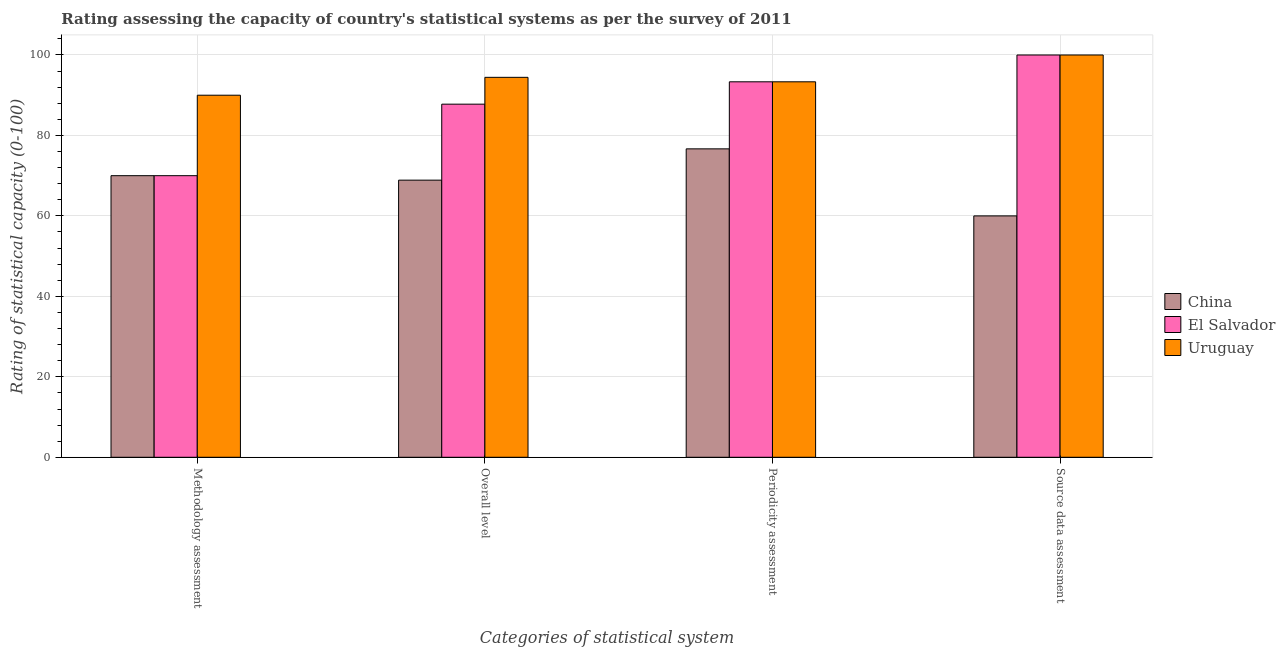How many groups of bars are there?
Offer a terse response. 4. Are the number of bars on each tick of the X-axis equal?
Your response must be concise. Yes. How many bars are there on the 2nd tick from the right?
Your answer should be compact. 3. What is the label of the 1st group of bars from the left?
Keep it short and to the point. Methodology assessment. What is the periodicity assessment rating in El Salvador?
Your answer should be very brief. 93.33. Across all countries, what is the maximum overall level rating?
Provide a short and direct response. 94.44. In which country was the methodology assessment rating maximum?
Offer a very short reply. Uruguay. What is the total overall level rating in the graph?
Offer a terse response. 251.11. What is the difference between the source data assessment rating in El Salvador and that in China?
Make the answer very short. 40. What is the difference between the periodicity assessment rating in China and the source data assessment rating in El Salvador?
Provide a short and direct response. -23.33. What is the average overall level rating per country?
Your response must be concise. 83.7. What is the difference between the overall level rating and methodology assessment rating in Uruguay?
Your answer should be very brief. 4.44. In how many countries, is the source data assessment rating greater than 68 ?
Keep it short and to the point. 2. Is the source data assessment rating in China less than that in Uruguay?
Make the answer very short. Yes. Is the difference between the methodology assessment rating in China and Uruguay greater than the difference between the source data assessment rating in China and Uruguay?
Offer a very short reply. Yes. What is the difference between the highest and the lowest periodicity assessment rating?
Provide a succinct answer. 16.67. In how many countries, is the methodology assessment rating greater than the average methodology assessment rating taken over all countries?
Ensure brevity in your answer.  1. What does the 2nd bar from the left in Source data assessment represents?
Make the answer very short. El Salvador. What does the 1st bar from the right in Periodicity assessment represents?
Give a very brief answer. Uruguay. Is it the case that in every country, the sum of the methodology assessment rating and overall level rating is greater than the periodicity assessment rating?
Give a very brief answer. Yes. How many countries are there in the graph?
Give a very brief answer. 3. What is the difference between two consecutive major ticks on the Y-axis?
Give a very brief answer. 20. Are the values on the major ticks of Y-axis written in scientific E-notation?
Keep it short and to the point. No. Does the graph contain any zero values?
Provide a succinct answer. No. Does the graph contain grids?
Offer a terse response. Yes. How are the legend labels stacked?
Provide a succinct answer. Vertical. What is the title of the graph?
Make the answer very short. Rating assessing the capacity of country's statistical systems as per the survey of 2011 . Does "China" appear as one of the legend labels in the graph?
Your answer should be compact. Yes. What is the label or title of the X-axis?
Your answer should be very brief. Categories of statistical system. What is the label or title of the Y-axis?
Ensure brevity in your answer.  Rating of statistical capacity (0-100). What is the Rating of statistical capacity (0-100) in Uruguay in Methodology assessment?
Your response must be concise. 90. What is the Rating of statistical capacity (0-100) of China in Overall level?
Your answer should be very brief. 68.89. What is the Rating of statistical capacity (0-100) in El Salvador in Overall level?
Offer a terse response. 87.78. What is the Rating of statistical capacity (0-100) in Uruguay in Overall level?
Provide a succinct answer. 94.44. What is the Rating of statistical capacity (0-100) of China in Periodicity assessment?
Your answer should be very brief. 76.67. What is the Rating of statistical capacity (0-100) of El Salvador in Periodicity assessment?
Offer a very short reply. 93.33. What is the Rating of statistical capacity (0-100) of Uruguay in Periodicity assessment?
Your answer should be compact. 93.33. What is the Rating of statistical capacity (0-100) in El Salvador in Source data assessment?
Your answer should be compact. 100. What is the Rating of statistical capacity (0-100) in Uruguay in Source data assessment?
Keep it short and to the point. 100. Across all Categories of statistical system, what is the maximum Rating of statistical capacity (0-100) of China?
Provide a succinct answer. 76.67. Across all Categories of statistical system, what is the maximum Rating of statistical capacity (0-100) in El Salvador?
Offer a very short reply. 100. Across all Categories of statistical system, what is the maximum Rating of statistical capacity (0-100) of Uruguay?
Offer a very short reply. 100. Across all Categories of statistical system, what is the minimum Rating of statistical capacity (0-100) in El Salvador?
Your answer should be compact. 70. Across all Categories of statistical system, what is the minimum Rating of statistical capacity (0-100) in Uruguay?
Offer a terse response. 90. What is the total Rating of statistical capacity (0-100) of China in the graph?
Keep it short and to the point. 275.56. What is the total Rating of statistical capacity (0-100) in El Salvador in the graph?
Provide a short and direct response. 351.11. What is the total Rating of statistical capacity (0-100) of Uruguay in the graph?
Provide a succinct answer. 377.78. What is the difference between the Rating of statistical capacity (0-100) of El Salvador in Methodology assessment and that in Overall level?
Give a very brief answer. -17.78. What is the difference between the Rating of statistical capacity (0-100) in Uruguay in Methodology assessment and that in Overall level?
Provide a short and direct response. -4.44. What is the difference between the Rating of statistical capacity (0-100) in China in Methodology assessment and that in Periodicity assessment?
Ensure brevity in your answer.  -6.67. What is the difference between the Rating of statistical capacity (0-100) in El Salvador in Methodology assessment and that in Periodicity assessment?
Give a very brief answer. -23.33. What is the difference between the Rating of statistical capacity (0-100) of Uruguay in Methodology assessment and that in Periodicity assessment?
Your response must be concise. -3.33. What is the difference between the Rating of statistical capacity (0-100) of Uruguay in Methodology assessment and that in Source data assessment?
Provide a succinct answer. -10. What is the difference between the Rating of statistical capacity (0-100) of China in Overall level and that in Periodicity assessment?
Give a very brief answer. -7.78. What is the difference between the Rating of statistical capacity (0-100) in El Salvador in Overall level and that in Periodicity assessment?
Give a very brief answer. -5.56. What is the difference between the Rating of statistical capacity (0-100) in Uruguay in Overall level and that in Periodicity assessment?
Make the answer very short. 1.11. What is the difference between the Rating of statistical capacity (0-100) of China in Overall level and that in Source data assessment?
Your response must be concise. 8.89. What is the difference between the Rating of statistical capacity (0-100) in El Salvador in Overall level and that in Source data assessment?
Your answer should be very brief. -12.22. What is the difference between the Rating of statistical capacity (0-100) of Uruguay in Overall level and that in Source data assessment?
Offer a terse response. -5.56. What is the difference between the Rating of statistical capacity (0-100) of China in Periodicity assessment and that in Source data assessment?
Your response must be concise. 16.67. What is the difference between the Rating of statistical capacity (0-100) in El Salvador in Periodicity assessment and that in Source data assessment?
Ensure brevity in your answer.  -6.67. What is the difference between the Rating of statistical capacity (0-100) of Uruguay in Periodicity assessment and that in Source data assessment?
Provide a short and direct response. -6.67. What is the difference between the Rating of statistical capacity (0-100) in China in Methodology assessment and the Rating of statistical capacity (0-100) in El Salvador in Overall level?
Ensure brevity in your answer.  -17.78. What is the difference between the Rating of statistical capacity (0-100) of China in Methodology assessment and the Rating of statistical capacity (0-100) of Uruguay in Overall level?
Your answer should be compact. -24.44. What is the difference between the Rating of statistical capacity (0-100) in El Salvador in Methodology assessment and the Rating of statistical capacity (0-100) in Uruguay in Overall level?
Provide a succinct answer. -24.44. What is the difference between the Rating of statistical capacity (0-100) in China in Methodology assessment and the Rating of statistical capacity (0-100) in El Salvador in Periodicity assessment?
Make the answer very short. -23.33. What is the difference between the Rating of statistical capacity (0-100) in China in Methodology assessment and the Rating of statistical capacity (0-100) in Uruguay in Periodicity assessment?
Your response must be concise. -23.33. What is the difference between the Rating of statistical capacity (0-100) of El Salvador in Methodology assessment and the Rating of statistical capacity (0-100) of Uruguay in Periodicity assessment?
Your response must be concise. -23.33. What is the difference between the Rating of statistical capacity (0-100) of China in Methodology assessment and the Rating of statistical capacity (0-100) of Uruguay in Source data assessment?
Provide a short and direct response. -30. What is the difference between the Rating of statistical capacity (0-100) of China in Overall level and the Rating of statistical capacity (0-100) of El Salvador in Periodicity assessment?
Give a very brief answer. -24.44. What is the difference between the Rating of statistical capacity (0-100) in China in Overall level and the Rating of statistical capacity (0-100) in Uruguay in Periodicity assessment?
Offer a very short reply. -24.44. What is the difference between the Rating of statistical capacity (0-100) in El Salvador in Overall level and the Rating of statistical capacity (0-100) in Uruguay in Periodicity assessment?
Ensure brevity in your answer.  -5.56. What is the difference between the Rating of statistical capacity (0-100) of China in Overall level and the Rating of statistical capacity (0-100) of El Salvador in Source data assessment?
Provide a succinct answer. -31.11. What is the difference between the Rating of statistical capacity (0-100) of China in Overall level and the Rating of statistical capacity (0-100) of Uruguay in Source data assessment?
Provide a succinct answer. -31.11. What is the difference between the Rating of statistical capacity (0-100) of El Salvador in Overall level and the Rating of statistical capacity (0-100) of Uruguay in Source data assessment?
Your answer should be compact. -12.22. What is the difference between the Rating of statistical capacity (0-100) in China in Periodicity assessment and the Rating of statistical capacity (0-100) in El Salvador in Source data assessment?
Keep it short and to the point. -23.33. What is the difference between the Rating of statistical capacity (0-100) in China in Periodicity assessment and the Rating of statistical capacity (0-100) in Uruguay in Source data assessment?
Offer a terse response. -23.33. What is the difference between the Rating of statistical capacity (0-100) in El Salvador in Periodicity assessment and the Rating of statistical capacity (0-100) in Uruguay in Source data assessment?
Offer a very short reply. -6.67. What is the average Rating of statistical capacity (0-100) of China per Categories of statistical system?
Make the answer very short. 68.89. What is the average Rating of statistical capacity (0-100) in El Salvador per Categories of statistical system?
Ensure brevity in your answer.  87.78. What is the average Rating of statistical capacity (0-100) in Uruguay per Categories of statistical system?
Offer a terse response. 94.44. What is the difference between the Rating of statistical capacity (0-100) of China and Rating of statistical capacity (0-100) of El Salvador in Methodology assessment?
Provide a short and direct response. 0. What is the difference between the Rating of statistical capacity (0-100) in China and Rating of statistical capacity (0-100) in Uruguay in Methodology assessment?
Make the answer very short. -20. What is the difference between the Rating of statistical capacity (0-100) in El Salvador and Rating of statistical capacity (0-100) in Uruguay in Methodology assessment?
Provide a short and direct response. -20. What is the difference between the Rating of statistical capacity (0-100) in China and Rating of statistical capacity (0-100) in El Salvador in Overall level?
Offer a very short reply. -18.89. What is the difference between the Rating of statistical capacity (0-100) in China and Rating of statistical capacity (0-100) in Uruguay in Overall level?
Your response must be concise. -25.56. What is the difference between the Rating of statistical capacity (0-100) of El Salvador and Rating of statistical capacity (0-100) of Uruguay in Overall level?
Provide a succinct answer. -6.67. What is the difference between the Rating of statistical capacity (0-100) of China and Rating of statistical capacity (0-100) of El Salvador in Periodicity assessment?
Provide a short and direct response. -16.67. What is the difference between the Rating of statistical capacity (0-100) in China and Rating of statistical capacity (0-100) in Uruguay in Periodicity assessment?
Keep it short and to the point. -16.67. What is the difference between the Rating of statistical capacity (0-100) of China and Rating of statistical capacity (0-100) of El Salvador in Source data assessment?
Your answer should be very brief. -40. What is the difference between the Rating of statistical capacity (0-100) of China and Rating of statistical capacity (0-100) of Uruguay in Source data assessment?
Ensure brevity in your answer.  -40. What is the difference between the Rating of statistical capacity (0-100) of El Salvador and Rating of statistical capacity (0-100) of Uruguay in Source data assessment?
Offer a terse response. 0. What is the ratio of the Rating of statistical capacity (0-100) in China in Methodology assessment to that in Overall level?
Offer a very short reply. 1.02. What is the ratio of the Rating of statistical capacity (0-100) of El Salvador in Methodology assessment to that in Overall level?
Provide a succinct answer. 0.8. What is the ratio of the Rating of statistical capacity (0-100) of Uruguay in Methodology assessment to that in Overall level?
Make the answer very short. 0.95. What is the ratio of the Rating of statistical capacity (0-100) of China in Methodology assessment to that in Periodicity assessment?
Provide a succinct answer. 0.91. What is the ratio of the Rating of statistical capacity (0-100) in El Salvador in Methodology assessment to that in Periodicity assessment?
Your answer should be compact. 0.75. What is the ratio of the Rating of statistical capacity (0-100) of Uruguay in Methodology assessment to that in Periodicity assessment?
Provide a short and direct response. 0.96. What is the ratio of the Rating of statistical capacity (0-100) of Uruguay in Methodology assessment to that in Source data assessment?
Provide a succinct answer. 0.9. What is the ratio of the Rating of statistical capacity (0-100) in China in Overall level to that in Periodicity assessment?
Offer a very short reply. 0.9. What is the ratio of the Rating of statistical capacity (0-100) of El Salvador in Overall level to that in Periodicity assessment?
Make the answer very short. 0.94. What is the ratio of the Rating of statistical capacity (0-100) in Uruguay in Overall level to that in Periodicity assessment?
Give a very brief answer. 1.01. What is the ratio of the Rating of statistical capacity (0-100) of China in Overall level to that in Source data assessment?
Your answer should be very brief. 1.15. What is the ratio of the Rating of statistical capacity (0-100) in El Salvador in Overall level to that in Source data assessment?
Provide a short and direct response. 0.88. What is the ratio of the Rating of statistical capacity (0-100) of Uruguay in Overall level to that in Source data assessment?
Make the answer very short. 0.94. What is the ratio of the Rating of statistical capacity (0-100) of China in Periodicity assessment to that in Source data assessment?
Make the answer very short. 1.28. What is the difference between the highest and the second highest Rating of statistical capacity (0-100) of China?
Offer a very short reply. 6.67. What is the difference between the highest and the second highest Rating of statistical capacity (0-100) in Uruguay?
Make the answer very short. 5.56. What is the difference between the highest and the lowest Rating of statistical capacity (0-100) in China?
Make the answer very short. 16.67. What is the difference between the highest and the lowest Rating of statistical capacity (0-100) of El Salvador?
Your answer should be compact. 30. What is the difference between the highest and the lowest Rating of statistical capacity (0-100) in Uruguay?
Make the answer very short. 10. 